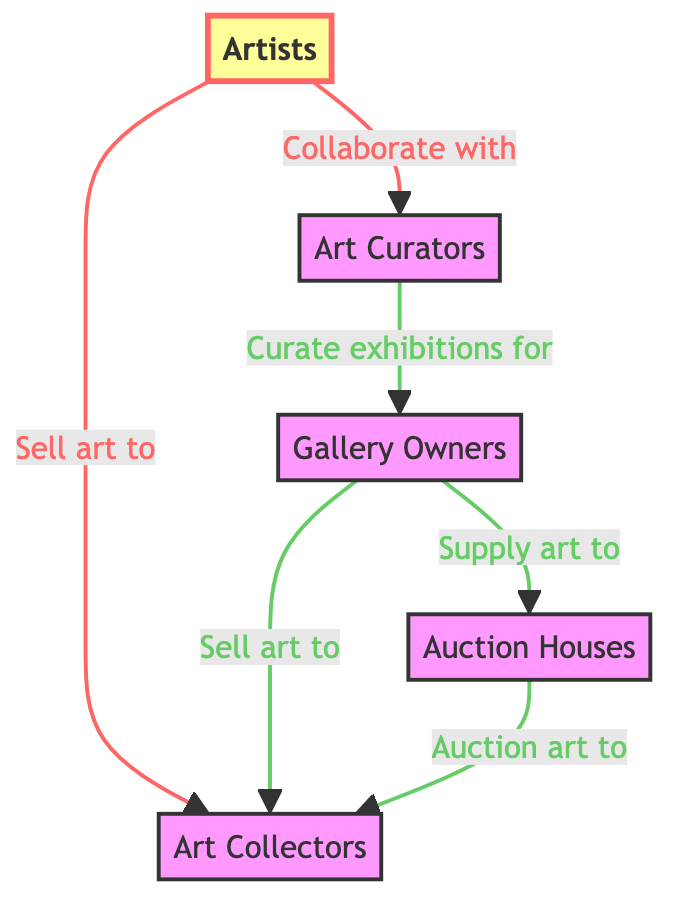What is the topmost level in the hierarchy? The diagram indicates that the topmost level in the hierarchy is Artists, as they are the first node in the flowchart.
Answer: Artists How many main nodes are present in the diagram? Counting the nodes in the diagram, we find five main entities: Artists, Art Collectors, Art Curators, Gallery Owners, and Auction Houses.
Answer: Five Who sells art to Art Collectors? The diagram shows that Artists sell art to Art Collectors, as indicated by the directed edge connecting these two nodes.
Answer: Artists Which node does Art Curators collaborate with? According to the diagram, Art Curators collaborate with Artists, as shown by the directed edge leading from Artists to Art Curators.
Answer: Artists What do Gallery Owners supply to Auction Houses? The diagram explicitly indicates that Gallery Owners supply art to Auction Houses, highlighting a direct relationship between these two nodes.
Answer: Art How many relationships involve Art Collectors? Analyzing the diagram, Art Collectors have two relationships: one being sold art by Artists and another where they are sold art by Gallery Owners.
Answer: Two Which node connects to Auction Houses? The diagram shows that Gallery Owners directly connect to Auction Houses, as indicated by the directed edge leading from Gallery Owners to Auction Houses.
Answer: Gallery Owners Who curates exhibitions for Gallery Owners? The diagram specifies that Art Curators curate exhibitions for Gallery Owners, showing a directed connection in the hierarchy.
Answer: Art Curators How does the flow from Artists to Auction Houses occur? The flow starts with Artists selling art to Art Collectors. Next, Gallery Owners sell art to Art Collectors and supply art to Auction Houses. Therefore, there is an indirect flow from Artists to Auction Houses through Art Collectors and Gallery Owners.
Answer: Indirectly through Art Collectors and Gallery Owners 